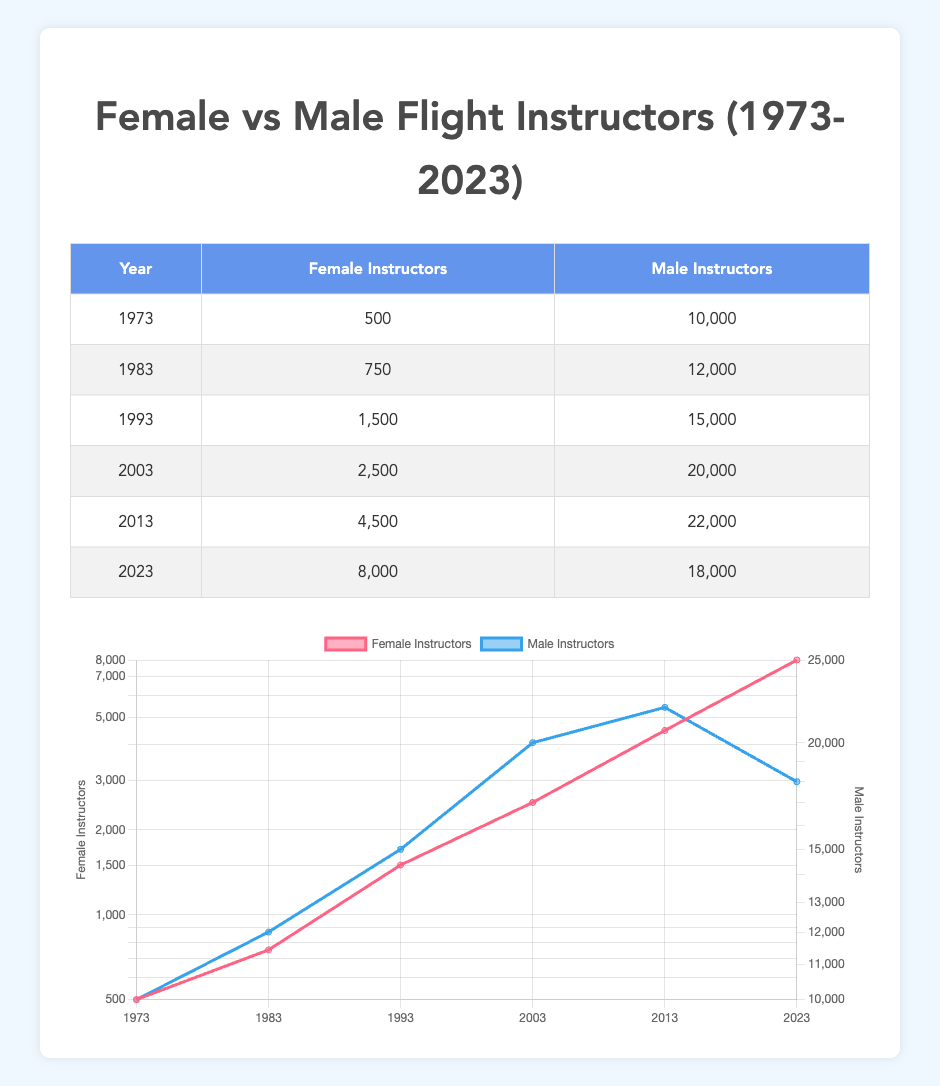What year had the highest number of female flight instructors? By inspecting the table, the number of female instructors increases over the years, with the last data point in 2023 showing 8000 instructors. Since none of the previous years have more than this figure, 2023 is the year with the highest number.
Answer: 2023 What is the difference in the number of male instructors between 2003 and 2023? In 2003, there were 20000 male instructors, and in 2023, this number decreased to 18000. The difference is calculated by subtracting the 2023 figure from the 2003 figure: 20000 - 18000 = 2000.
Answer: 2000 In which decade did the number of female flight instructors double compared to the previous decade? Looking at the data, in 1993 there were 1500 female instructors, and by 2003, there were 2500. This shows an increase of 1000 instructors but is not double. However, from 2013 to 2023, the number rose from 4500 to 8000, which is more than a doubling (8000 is approximately 1.78 times 4500). Thus, the decade of 2013 to 2023 is the most significant growth.
Answer: 2013-2023 Is it true that the number of male instructors was always greater than female instructors throughout the years? Yes, by checking each year’s data, it’s evident that in every year listed, the number of male flight instructors has always been higher than that of female instructors.
Answer: Yes What was the percentage increase in female flight instructors from 1973 to 2023? The number of female instructors in 1973 was 500 and increased to 8000 by 2023. To find the percentage increase, the formula is ((8000 - 500) / 500) * 100. This results in (7500 / 500) * 100 = 1500%.
Answer: 1500% How many more male instructors were there in 2013 than in 2003? In 2013, there were 22000 male instructors and in 2003, there were 20000. Subtracting these, 22000 - 20000 = 2000, shows that there were 2000 more male instructors in 2013 compared to 2003.
Answer: 2000 